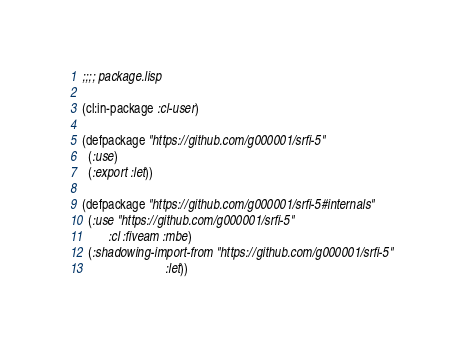Convert code to text. <code><loc_0><loc_0><loc_500><loc_500><_Lisp_>;;;; package.lisp

(cl:in-package :cl-user)

(defpackage "https://github.com/g000001/srfi-5"
  (:use)
  (:export :let))

(defpackage "https://github.com/g000001/srfi-5#internals"
  (:use "https://github.com/g000001/srfi-5"
        :cl :fiveam :mbe)
  (:shadowing-import-from "https://github.com/g000001/srfi-5"
                          :let))

</code> 